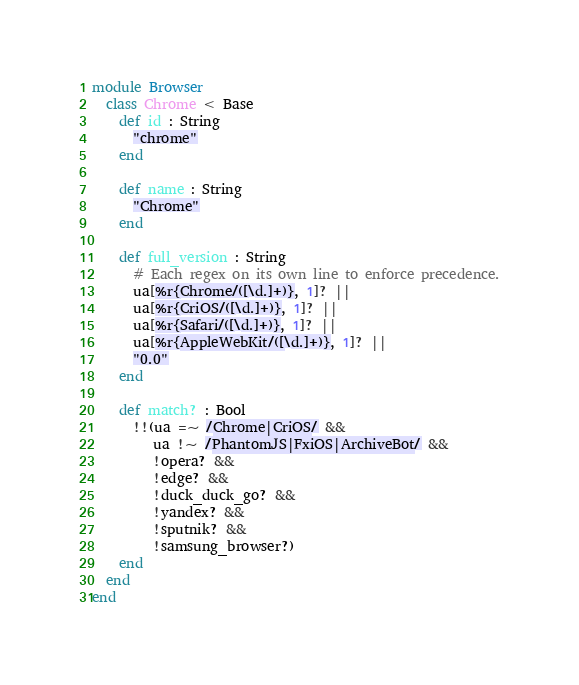Convert code to text. <code><loc_0><loc_0><loc_500><loc_500><_Crystal_>module Browser
  class Chrome < Base
    def id : String
      "chrome"
    end

    def name : String
      "Chrome"
    end

    def full_version : String
      # Each regex on its own line to enforce precedence.
      ua[%r{Chrome/([\d.]+)}, 1]? ||
      ua[%r{CriOS/([\d.]+)}, 1]? ||
      ua[%r{Safari/([\d.]+)}, 1]? ||
      ua[%r{AppleWebKit/([\d.]+)}, 1]? ||
      "0.0"
    end

    def match? : Bool
      !!(ua =~ /Chrome|CriOS/ &&
         ua !~ /PhantomJS|FxiOS|ArchiveBot/ &&
         !opera? &&
         !edge? &&
         !duck_duck_go? &&
         !yandex? &&
         !sputnik? &&
         !samsung_browser?)
    end
  end
end
</code> 